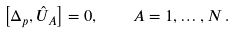Convert formula to latex. <formula><loc_0><loc_0><loc_500><loc_500>\left [ \Delta _ { p } , \hat { U } _ { A } \right ] = 0 , \quad A = 1 , \dots , N \, .</formula> 